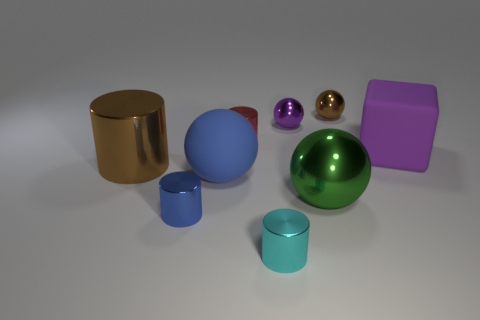Subtract all green spheres. How many spheres are left? 3 Subtract all small brown spheres. How many spheres are left? 3 Subtract 1 cylinders. How many cylinders are left? 3 Subtract all yellow balls. Subtract all cyan blocks. How many balls are left? 4 Subtract all cubes. How many objects are left? 8 Add 9 red things. How many red things exist? 10 Subtract 0 cyan balls. How many objects are left? 9 Subtract all small balls. Subtract all green shiny balls. How many objects are left? 6 Add 6 purple rubber blocks. How many purple rubber blocks are left? 7 